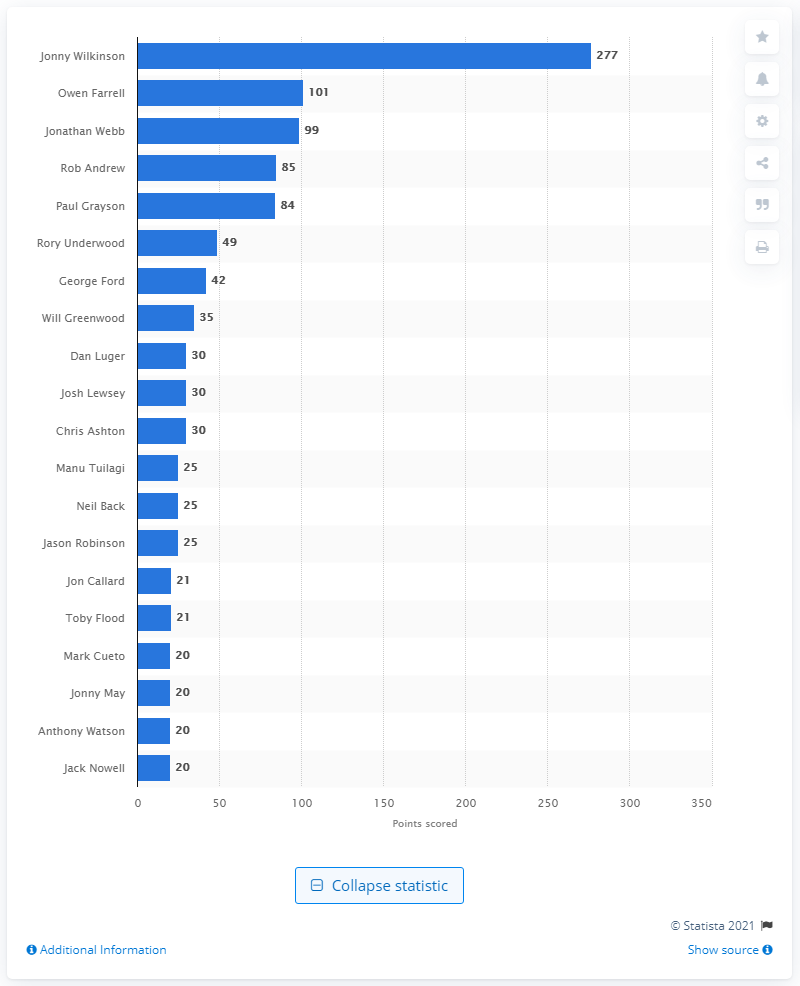Give some essential details in this illustration. With a total of 27 points scored, Jonny Wilkinson holds the record for the most points scored at the Rugby World Cup. Jonny Wilkinson has a total of 277 points at the Rugby World Cup. England's next highest point scorer at the RWC is Owen Farrell, who has demonstrated his impressive skills and abilities on the rugby field. 